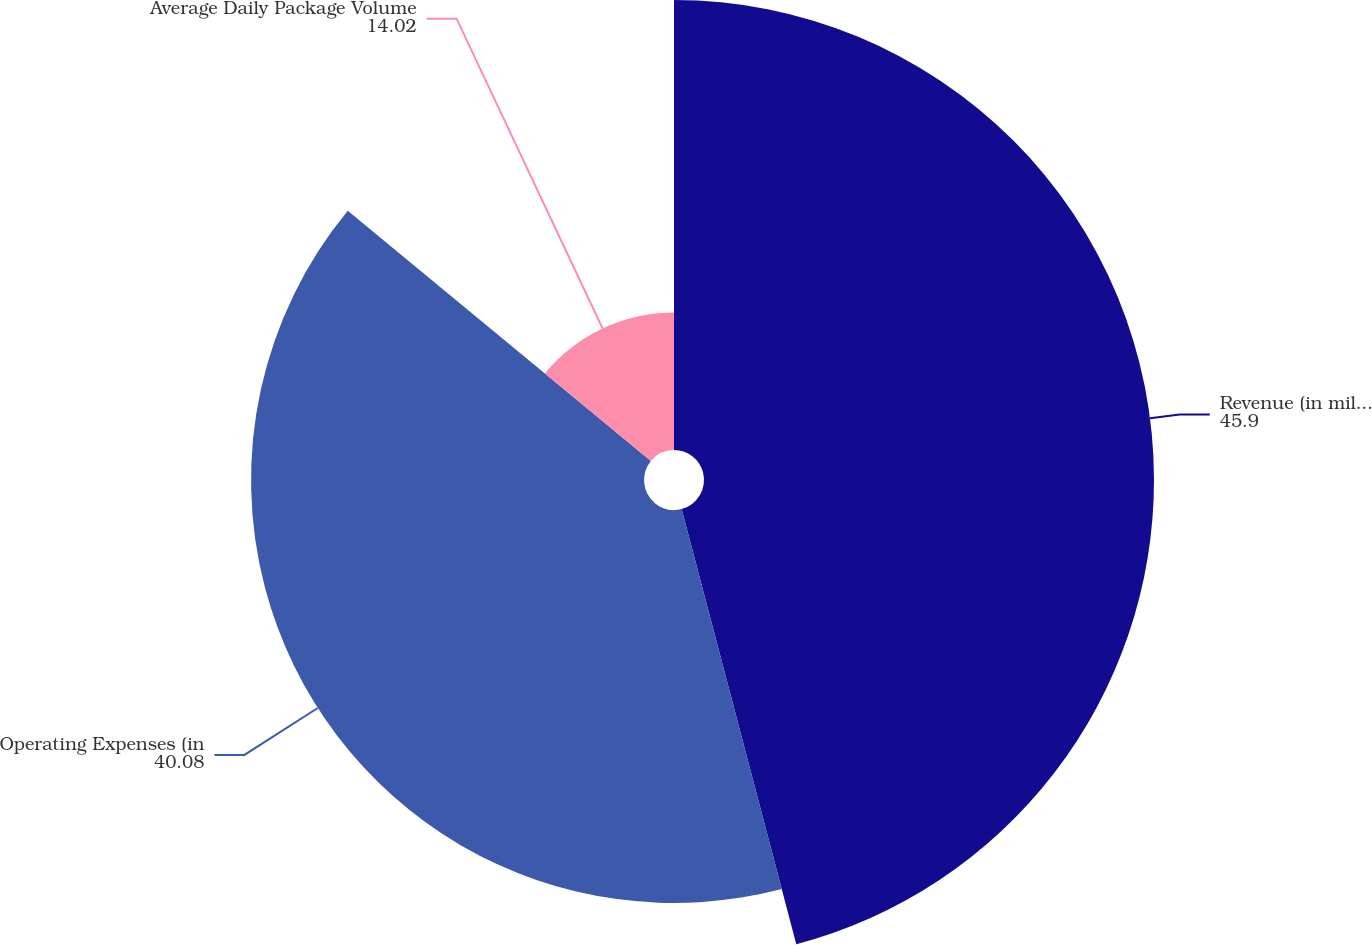Convert chart to OTSL. <chart><loc_0><loc_0><loc_500><loc_500><pie_chart><fcel>Revenue (in millions)<fcel>Operating Expenses (in<fcel>Average Daily Package Volume<nl><fcel>45.9%<fcel>40.08%<fcel>14.02%<nl></chart> 